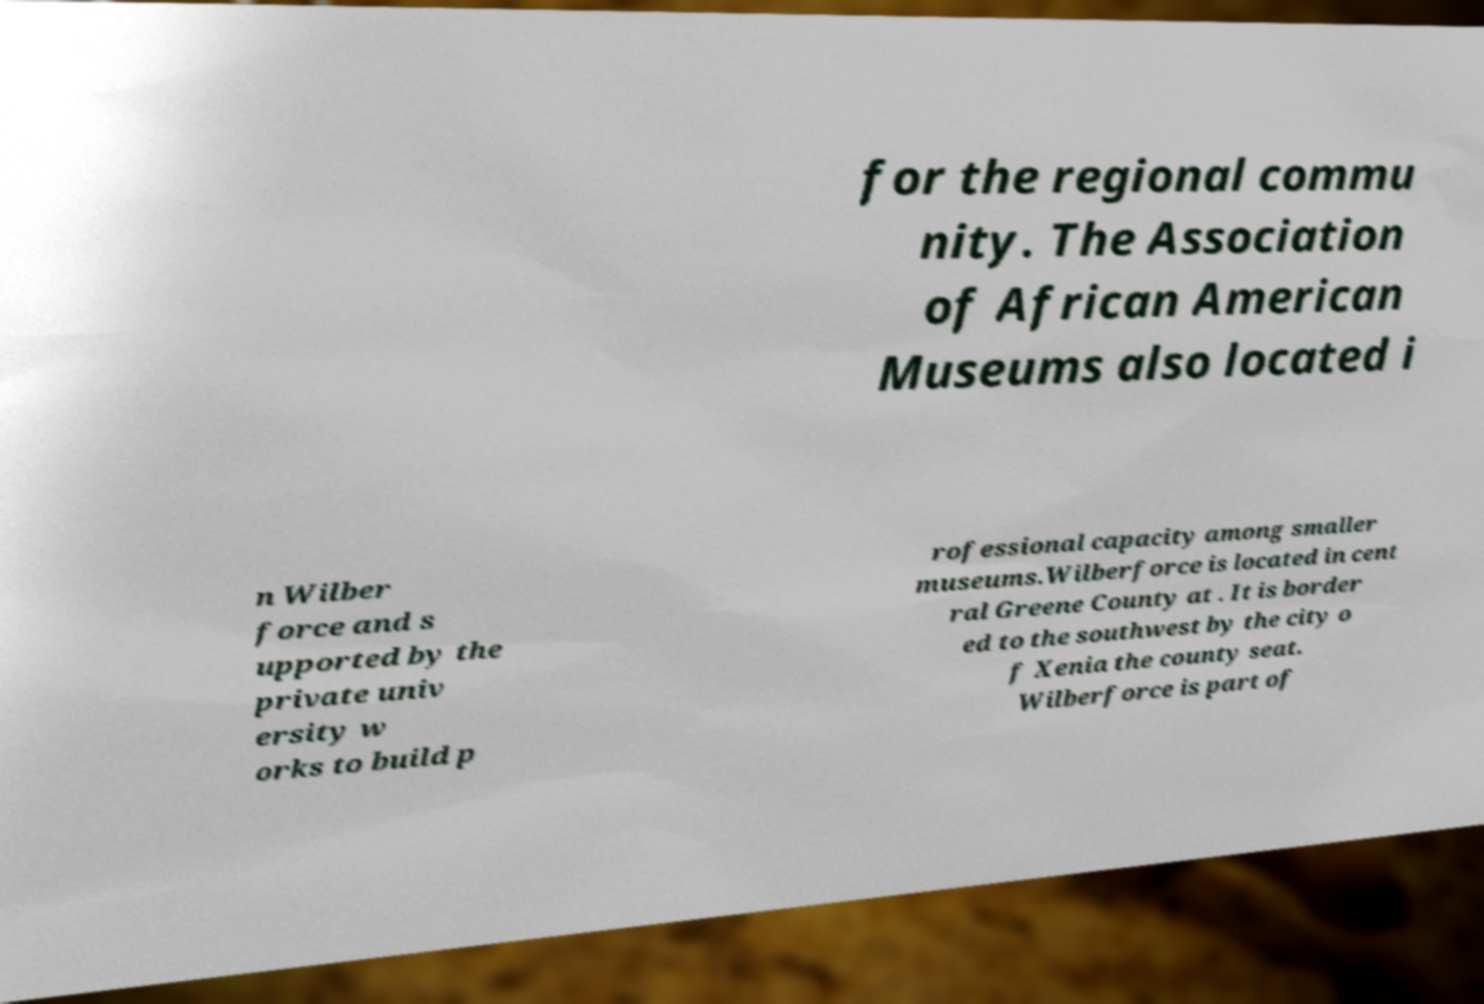Could you assist in decoding the text presented in this image and type it out clearly? for the regional commu nity. The Association of African American Museums also located i n Wilber force and s upported by the private univ ersity w orks to build p rofessional capacity among smaller museums.Wilberforce is located in cent ral Greene County at . It is border ed to the southwest by the city o f Xenia the county seat. Wilberforce is part of 